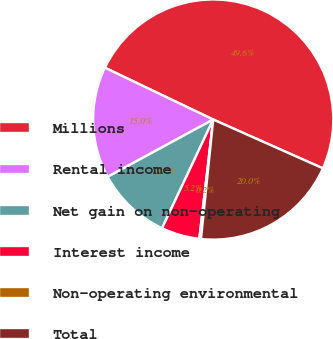Convert chart. <chart><loc_0><loc_0><loc_500><loc_500><pie_chart><fcel>Millions<fcel>Rental income<fcel>Net gain on non-operating<fcel>Interest income<fcel>Non-operating environmental<fcel>Total<nl><fcel>49.56%<fcel>15.02%<fcel>10.09%<fcel>5.15%<fcel>0.22%<fcel>19.96%<nl></chart> 